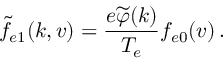Convert formula to latex. <formula><loc_0><loc_0><loc_500><loc_500>\widetilde { f } _ { e 1 } ( k , v ) = \frac { e \widetilde { \varphi } ( k ) } { T _ { e } } f _ { e 0 } ( v ) \, .</formula> 